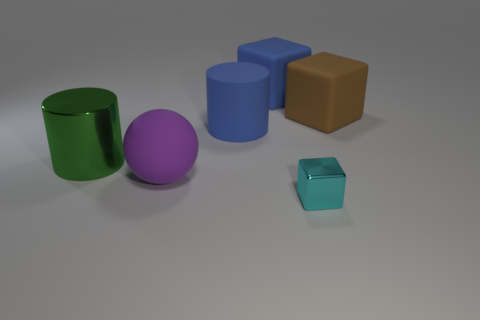How many yellow objects are cylinders or big shiny objects?
Make the answer very short. 0. There is a rubber block that is left of the cyan object; is it the same color as the large rubber cylinder?
Provide a short and direct response. Yes. What is the shape of the big purple thing that is made of the same material as the brown cube?
Provide a succinct answer. Sphere. What is the color of the object that is in front of the large green metal cylinder and right of the purple object?
Provide a succinct answer. Cyan. What is the size of the block that is in front of the matte cube in front of the large blue cube?
Make the answer very short. Small. Is there a big matte cube of the same color as the large metal object?
Ensure brevity in your answer.  No. Are there the same number of large spheres to the left of the large blue cube and small cyan metal blocks?
Your response must be concise. Yes. What number of metal blocks are there?
Give a very brief answer. 1. What is the shape of the thing that is right of the big blue rubber cube and on the left side of the large brown cube?
Provide a short and direct response. Cube. There is a big cube that is to the right of the small cyan metal block; does it have the same color as the cylinder right of the large shiny object?
Make the answer very short. No. 